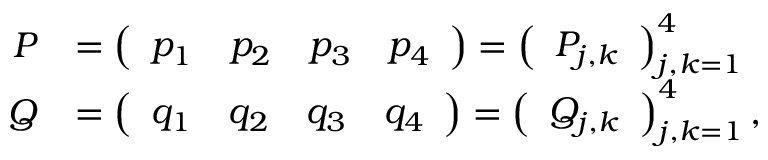Convert formula to latex. <formula><loc_0><loc_0><loc_500><loc_500>\begin{array} { r l } { P } & { = \left ( \begin{array} { l l l l } { p _ { 1 } } & { p _ { 2 } } & { p _ { 3 } } & { p _ { 4 } } \end{array} \right ) = \left ( \begin{array} { l } { P _ { j , k } } \end{array} \right ) _ { j , k = 1 } ^ { 4 } } \\ { Q } & { = \left ( \begin{array} { l l l l } { q _ { 1 } } & { q _ { 2 } } & { q _ { 3 } } & { q _ { 4 } } \end{array} \right ) = \left ( \begin{array} { l } { Q _ { j , k } } \end{array} \right ) _ { j , k = 1 } ^ { 4 } , } \end{array}</formula> 